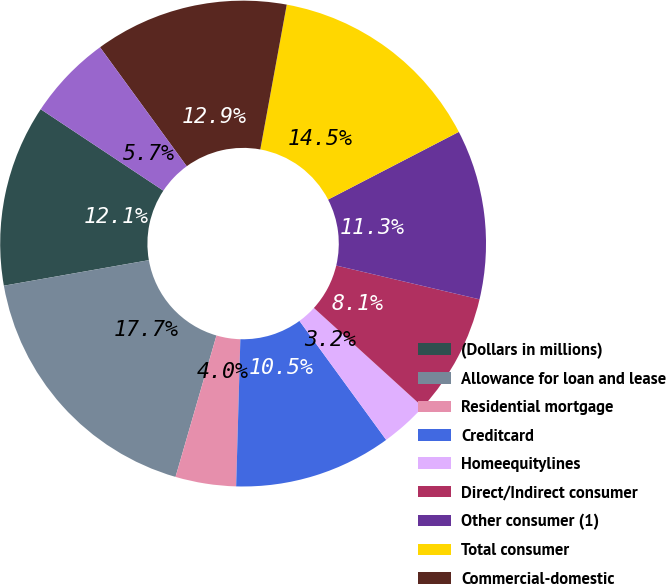<chart> <loc_0><loc_0><loc_500><loc_500><pie_chart><fcel>(Dollars in millions)<fcel>Allowance for loan and lease<fcel>Residential mortgage<fcel>Creditcard<fcel>Homeequitylines<fcel>Direct/Indirect consumer<fcel>Other consumer (1)<fcel>Total consumer<fcel>Commercial-domestic<fcel>Commercial real estate<nl><fcel>12.1%<fcel>17.74%<fcel>4.03%<fcel>10.48%<fcel>3.23%<fcel>8.06%<fcel>11.29%<fcel>14.52%<fcel>12.9%<fcel>5.65%<nl></chart> 